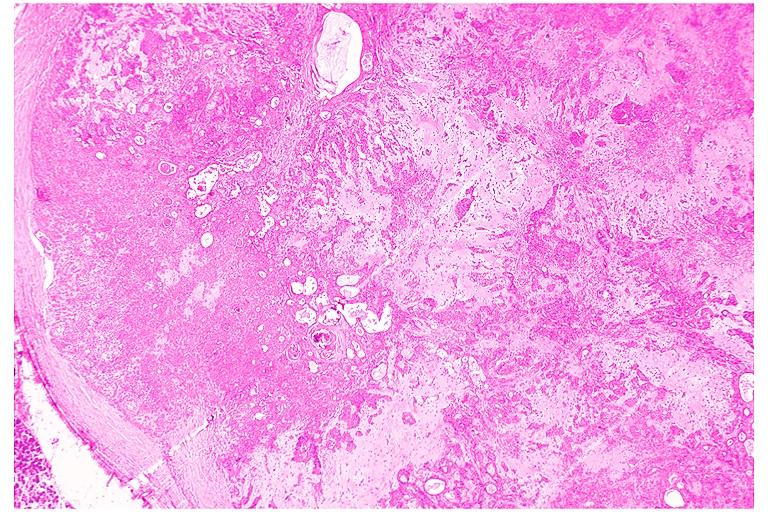where is this?
Answer the question using a single word or phrase. Oral 